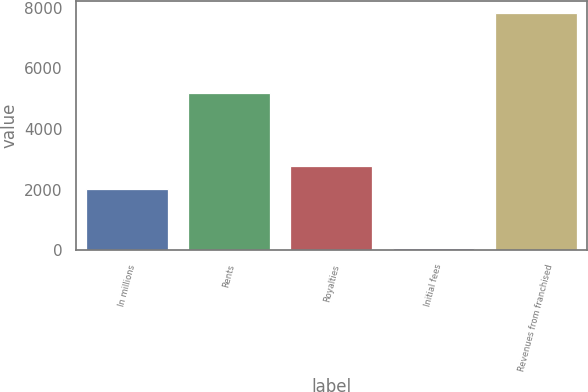Convert chart. <chart><loc_0><loc_0><loc_500><loc_500><bar_chart><fcel>In millions<fcel>Rents<fcel>Royalties<fcel>Initial fees<fcel>Revenues from franchised<nl><fcel>2010<fcel>5198.4<fcel>2787.76<fcel>63.7<fcel>7841.3<nl></chart> 